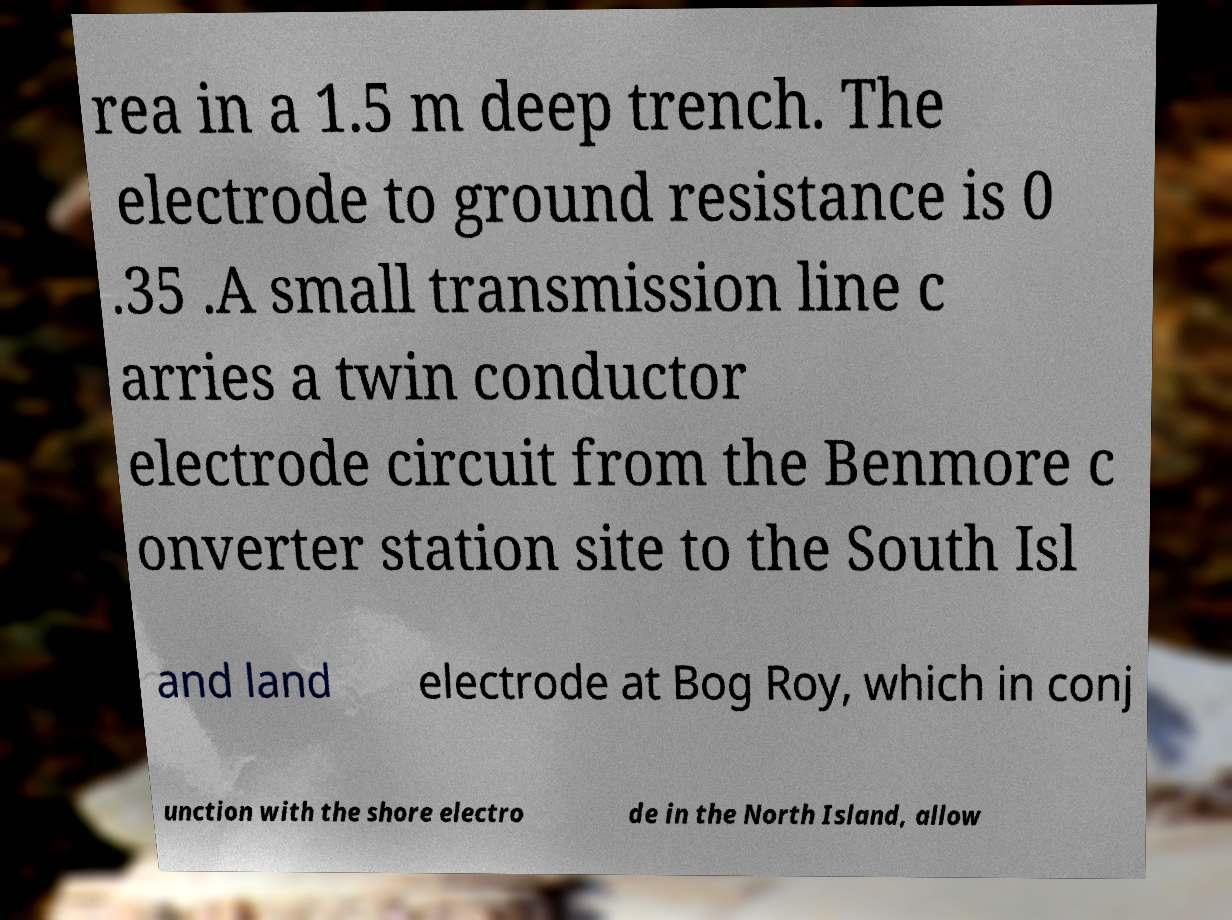Can you read and provide the text displayed in the image?This photo seems to have some interesting text. Can you extract and type it out for me? rea in a 1.5 m deep trench. The electrode to ground resistance is 0 .35 .A small transmission line c arries a twin conductor electrode circuit from the Benmore c onverter station site to the South Isl and land electrode at Bog Roy, which in conj unction with the shore electro de in the North Island, allow 